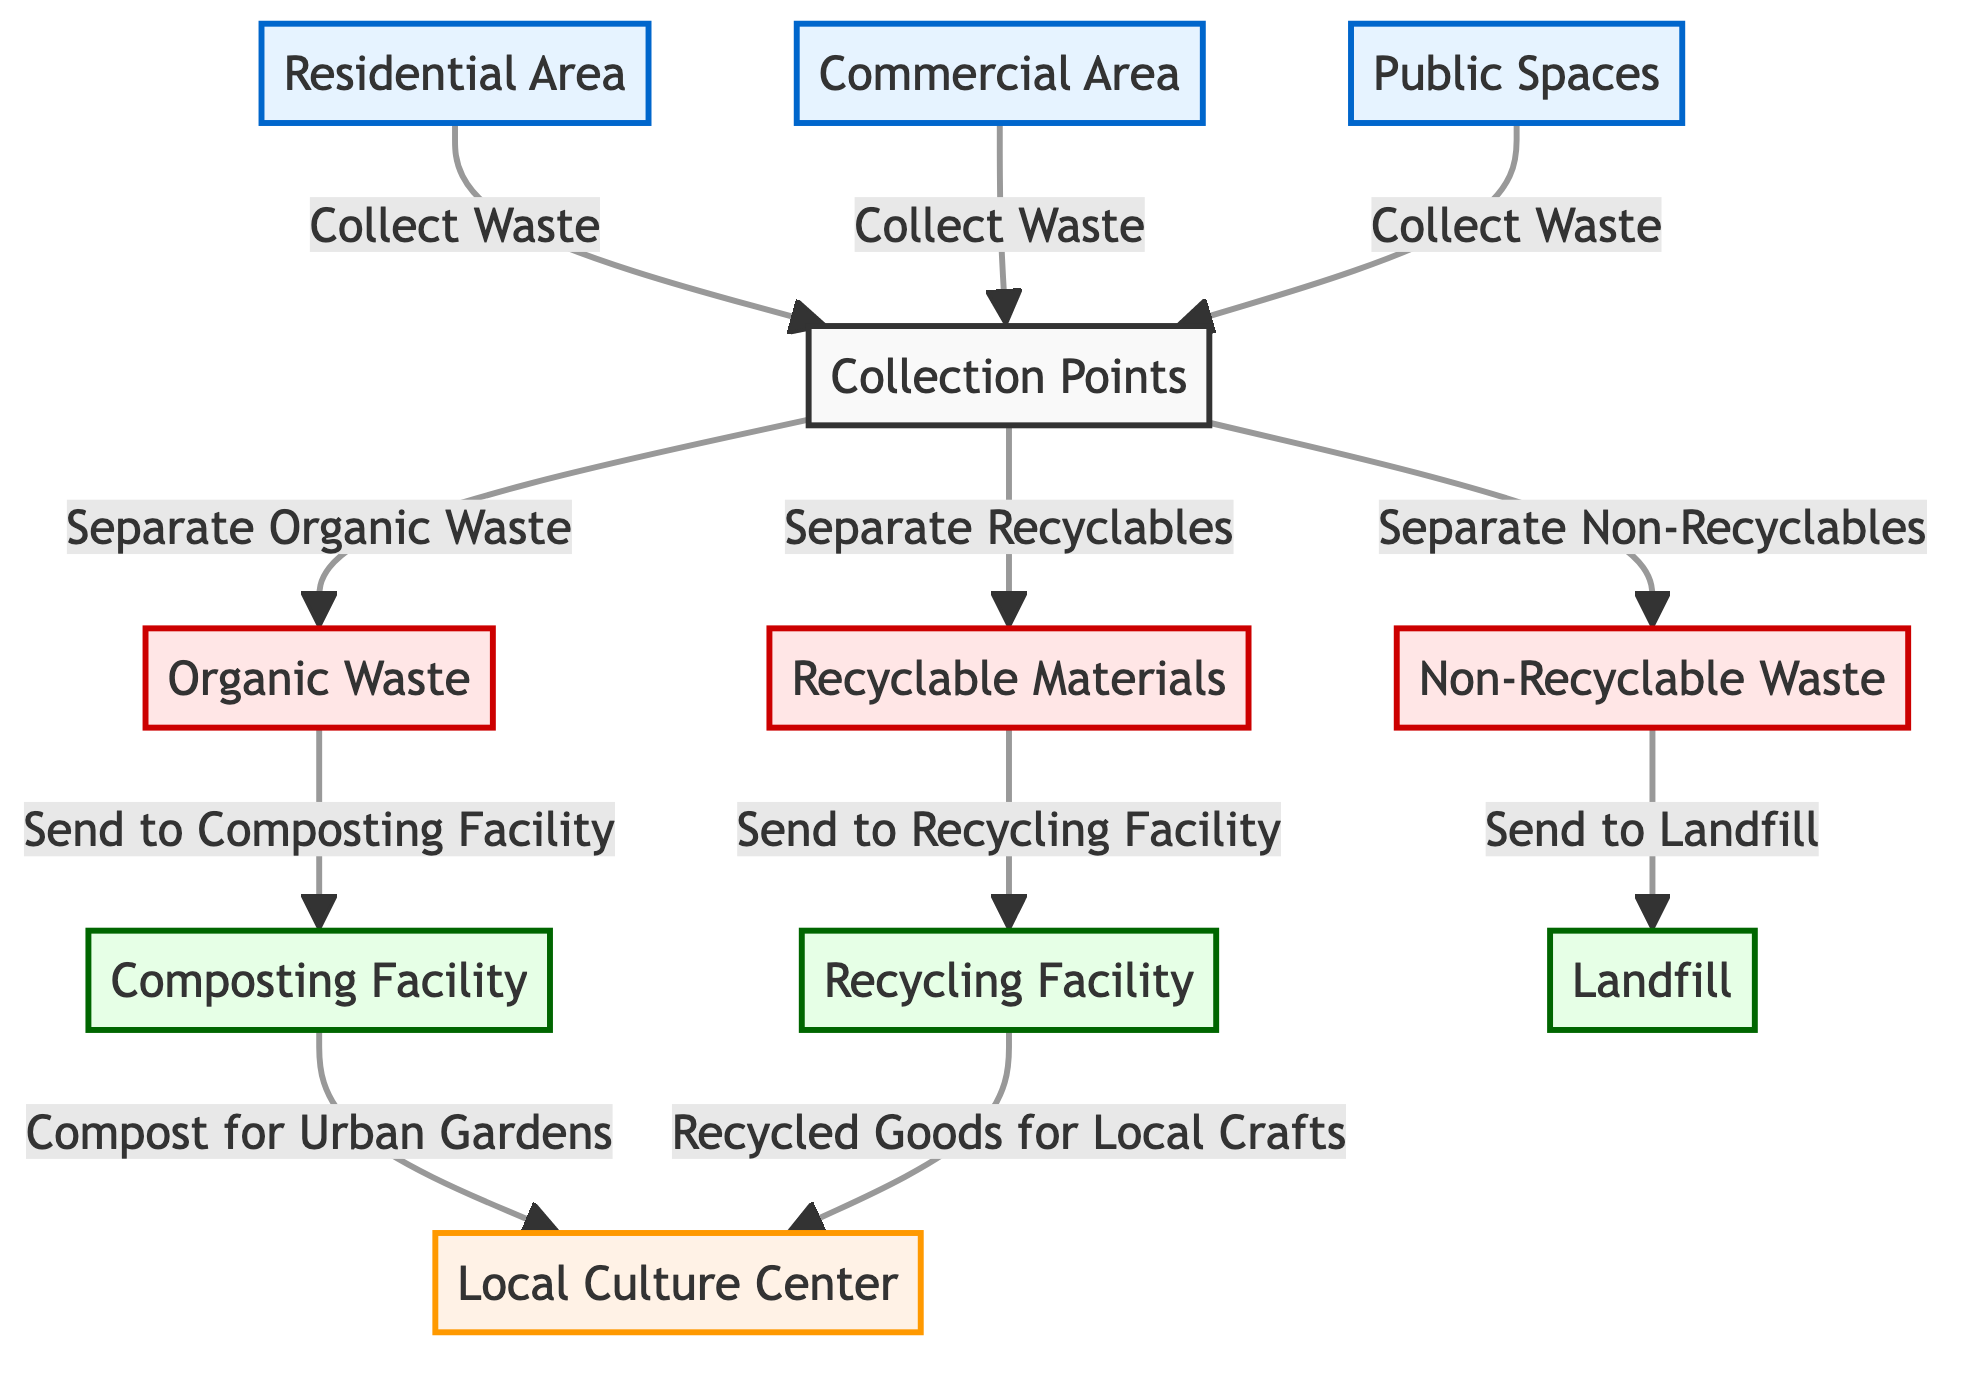What are the three key areas in the waste management system? The diagram shows three areas: Residential Area, Commercial Area, and Public Spaces that collect waste.
Answer: Residential Area, Commercial Area, Public Spaces What happens to organic waste in the system? Organic waste is directed to the composting facility, which then sends compost to the local culture center for urban gardens.
Answer: Composting Facility What type of waste is sent to the landfill? Non-recyclable waste is designated to be sent to the landfill according to the diagram.
Answer: Non-Recyclable Waste How many facilities are shown in the diagram? The diagram illustrates three facilities: Composting Facility, Recycling Facility, and Landfill, representing the different disposal paths.
Answer: Three What do the recyclable materials provide to the local culture center? The recyclable materials processed at the recycling facility are used to create recycled goods for the local crafts, as shown in the flowchart.
Answer: Recycled Goods for Local Crafts Which type of waste is separated and sent to the composting facility? Organic waste is separated from collection points and is specifically sent to the composting facility for processing.
Answer: Organic Waste Where do the compost from the composting facility go? The compost created from organic waste is sent from the composting facility to the local culture center for urban gardens, indicating a cultural aspect of waste management.
Answer: Local Culture Center Which areas contribute waste to the collection points? The residential area, commercial area, and public spaces all collect and contribute waste to the collection points as depicted in the diagram.
Answer: Residential Area, Commercial Area, Public Spaces 